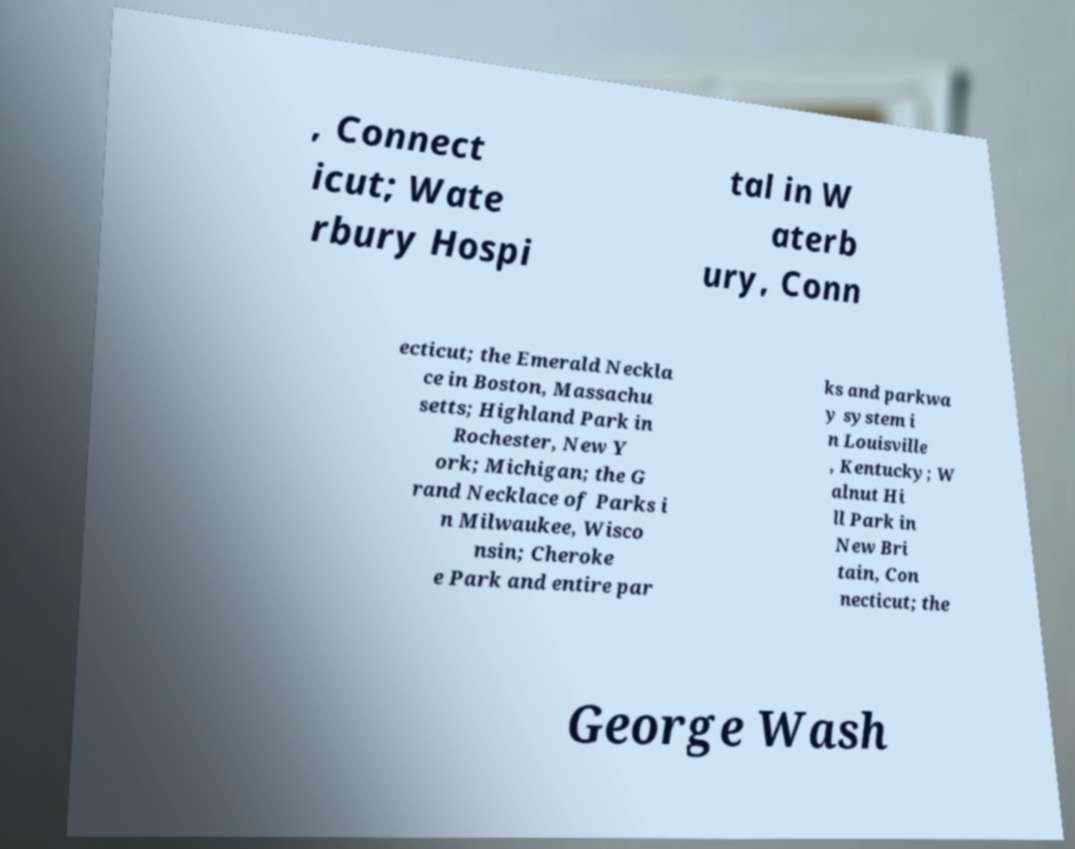There's text embedded in this image that I need extracted. Can you transcribe it verbatim? , Connect icut; Wate rbury Hospi tal in W aterb ury, Conn ecticut; the Emerald Neckla ce in Boston, Massachu setts; Highland Park in Rochester, New Y ork; Michigan; the G rand Necklace of Parks i n Milwaukee, Wisco nsin; Cheroke e Park and entire par ks and parkwa y system i n Louisville , Kentucky; W alnut Hi ll Park in New Bri tain, Con necticut; the George Wash 